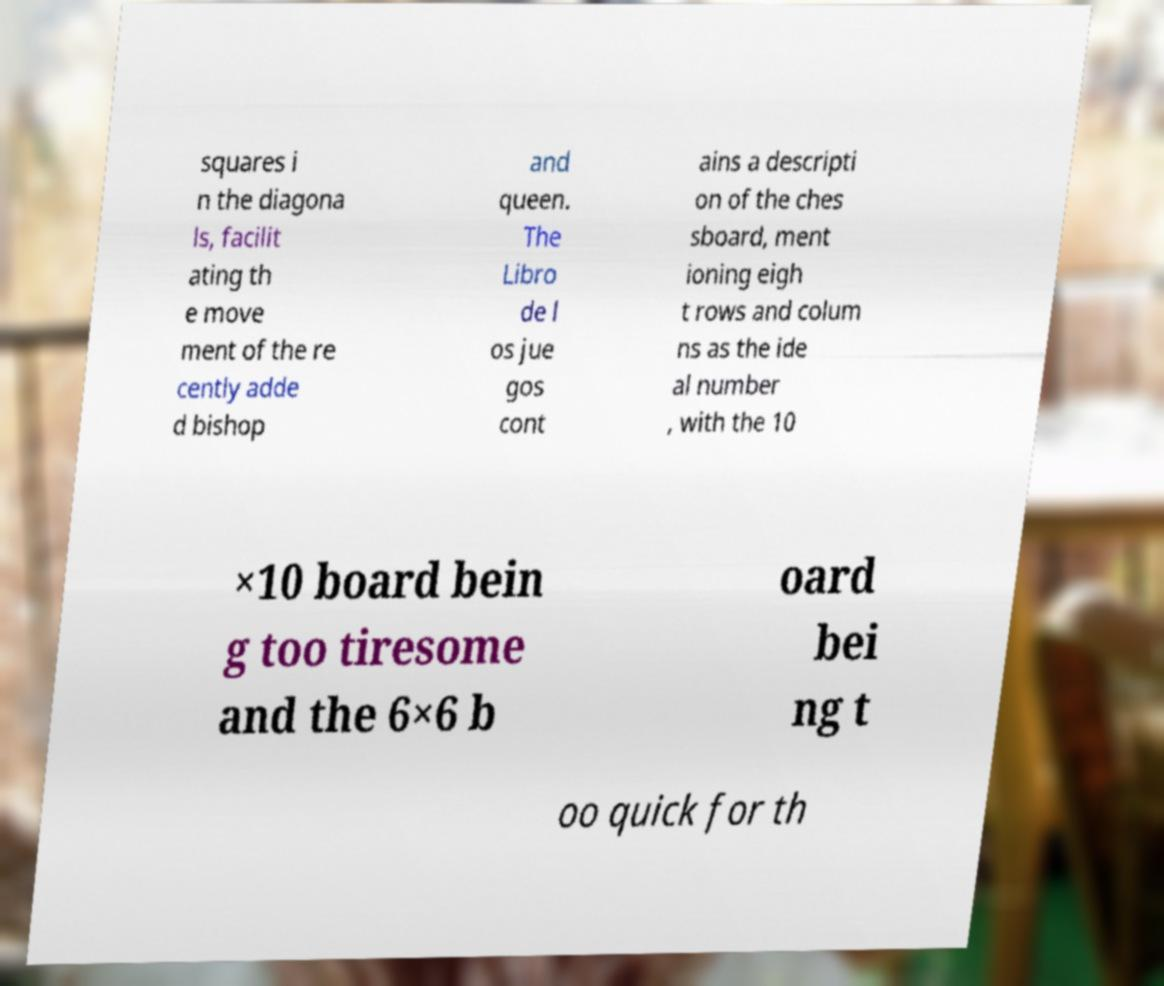Could you assist in decoding the text presented in this image and type it out clearly? squares i n the diagona ls, facilit ating th e move ment of the re cently adde d bishop and queen. The Libro de l os jue gos cont ains a descripti on of the ches sboard, ment ioning eigh t rows and colum ns as the ide al number , with the 10 ×10 board bein g too tiresome and the 6×6 b oard bei ng t oo quick for th 